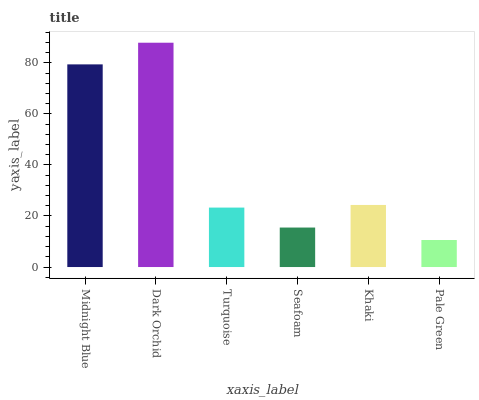Is Pale Green the minimum?
Answer yes or no. Yes. Is Dark Orchid the maximum?
Answer yes or no. Yes. Is Turquoise the minimum?
Answer yes or no. No. Is Turquoise the maximum?
Answer yes or no. No. Is Dark Orchid greater than Turquoise?
Answer yes or no. Yes. Is Turquoise less than Dark Orchid?
Answer yes or no. Yes. Is Turquoise greater than Dark Orchid?
Answer yes or no. No. Is Dark Orchid less than Turquoise?
Answer yes or no. No. Is Khaki the high median?
Answer yes or no. Yes. Is Turquoise the low median?
Answer yes or no. Yes. Is Seafoam the high median?
Answer yes or no. No. Is Seafoam the low median?
Answer yes or no. No. 